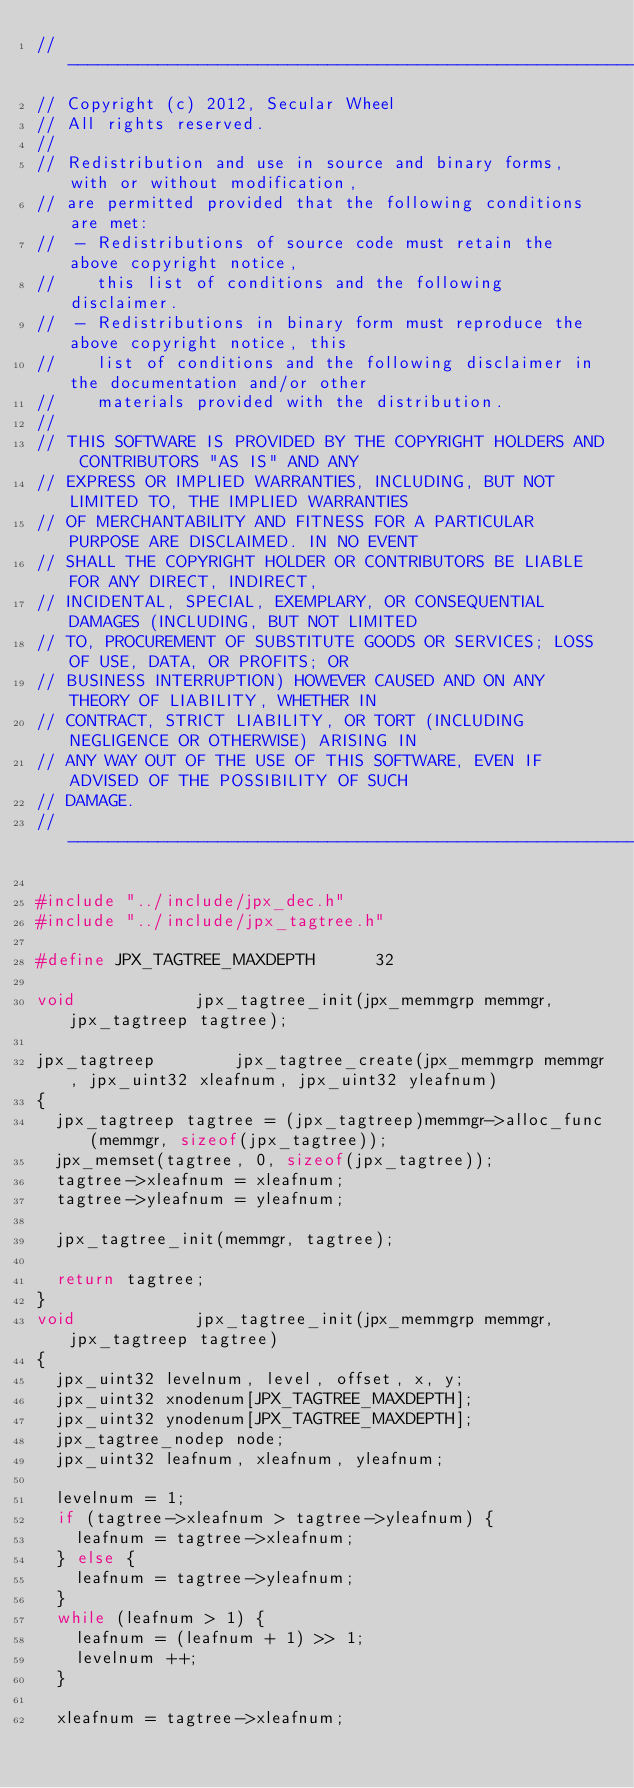<code> <loc_0><loc_0><loc_500><loc_500><_C_>//--------------------------------------------------------------------------------
// Copyright (c) 2012, Secular Wheel
// All rights reserved.
//
// Redistribution and use in source and binary forms, with or without modification,
// are permitted provided that the following conditions are met:
//	- Redistributions of source code must retain the above copyright notice, 
//	  this list of conditions and the following disclaimer.
//	- Redistributions in binary form must reproduce the above copyright notice, this
//	  list of conditions and the following disclaimer in the documentation and/or other 
//	  materials provided with the distribution.
//
// THIS SOFTWARE IS PROVIDED BY THE COPYRIGHT HOLDERS AND CONTRIBUTORS "AS IS" AND ANY
// EXPRESS OR IMPLIED WARRANTIES, INCLUDING, BUT NOT LIMITED TO, THE IMPLIED WARRANTIES
// OF MERCHANTABILITY AND FITNESS FOR A PARTICULAR PURPOSE ARE DISCLAIMED. IN NO EVENT
// SHALL THE COPYRIGHT HOLDER OR CONTRIBUTORS BE LIABLE FOR ANY DIRECT, INDIRECT, 
// INCIDENTAL, SPECIAL, EXEMPLARY, OR CONSEQUENTIAL DAMAGES (INCLUDING, BUT NOT LIMITED
// TO, PROCUREMENT OF SUBSTITUTE GOODS OR SERVICES; LOSS OF USE, DATA, OR PROFITS; OR 
// BUSINESS INTERRUPTION) HOWEVER CAUSED AND ON ANY THEORY OF LIABILITY, WHETHER IN 
// CONTRACT, STRICT LIABILITY, OR TORT (INCLUDING NEGLIGENCE OR OTHERWISE) ARISING IN
// ANY WAY OUT OF THE USE OF THIS SOFTWARE, EVEN IF ADVISED OF THE POSSIBILITY OF SUCH
// DAMAGE.
//--------------------------------------------------------------------------------

#include "../include/jpx_dec.h"
#include "../include/jpx_tagtree.h"

#define JPX_TAGTREE_MAXDEPTH			32

void						jpx_tagtree_init(jpx_memmgrp memmgr, jpx_tagtreep tagtree);

jpx_tagtreep				jpx_tagtree_create(jpx_memmgrp memmgr, jpx_uint32 xleafnum, jpx_uint32 yleafnum)
{
	jpx_tagtreep tagtree = (jpx_tagtreep)memmgr->alloc_func(memmgr, sizeof(jpx_tagtree));
	jpx_memset(tagtree, 0, sizeof(jpx_tagtree));
	tagtree->xleafnum = xleafnum;
	tagtree->yleafnum = yleafnum;

	jpx_tagtree_init(memmgr, tagtree);

	return tagtree;
}
void						jpx_tagtree_init(jpx_memmgrp memmgr, jpx_tagtreep tagtree)
{
	jpx_uint32 levelnum, level, offset, x, y;
	jpx_uint32 xnodenum[JPX_TAGTREE_MAXDEPTH];
	jpx_uint32 ynodenum[JPX_TAGTREE_MAXDEPTH];
	jpx_tagtree_nodep node;
	jpx_uint32 leafnum, xleafnum, yleafnum;

	levelnum = 1;
	if (tagtree->xleafnum > tagtree->yleafnum) {
		leafnum = tagtree->xleafnum;
	} else {
		leafnum = tagtree->yleafnum;
	}
	while (leafnum > 1) {
		leafnum = (leafnum + 1) >> 1;
		levelnum ++;
	}

	xleafnum = tagtree->xleafnum;</code> 